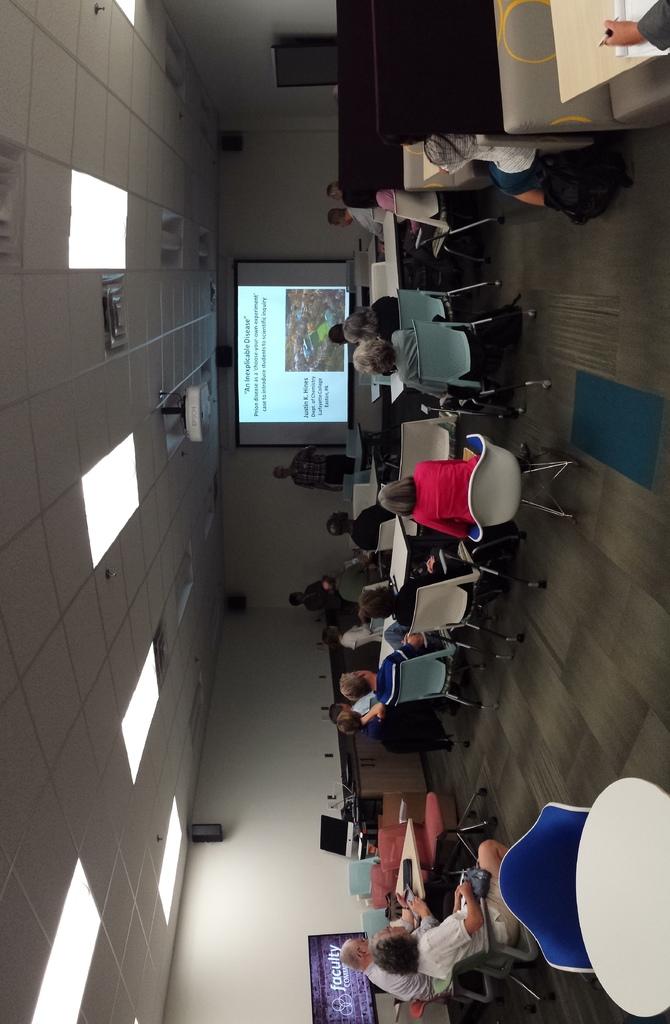What is the title at the top of this powerpoint.  it's in quote?
Give a very brief answer. An inexplicable disease. 